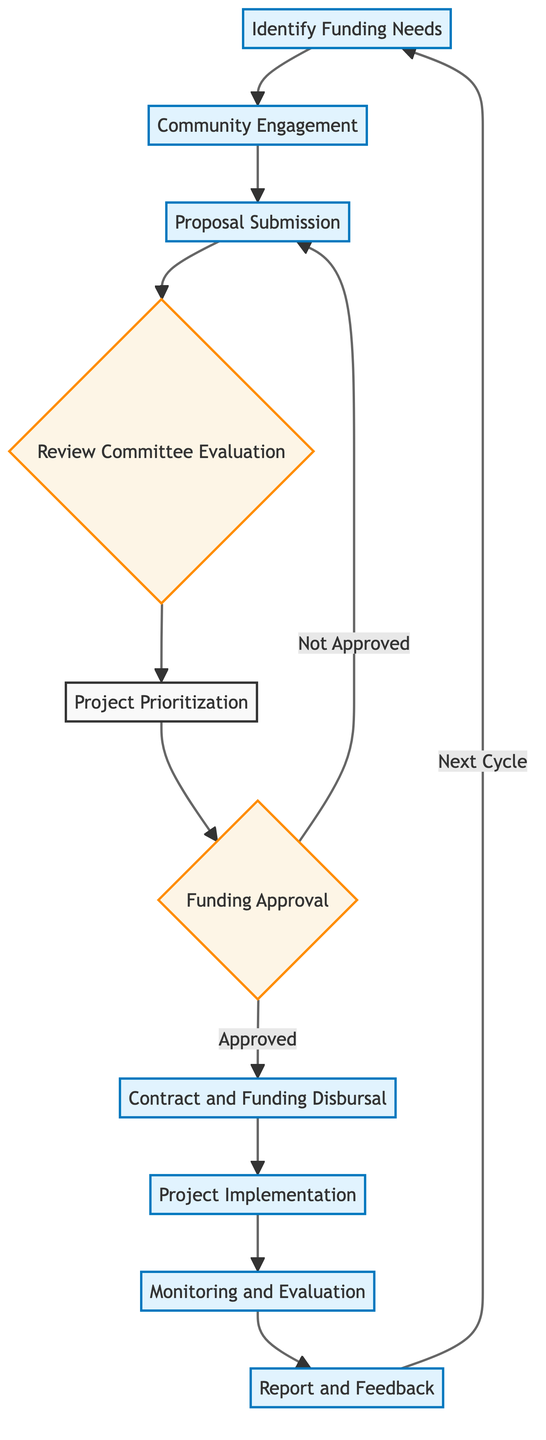What is the first step in the decision-making process? The first step in the diagram is "Identify Funding Needs," which is highlighted as the starting point before community engagement takes place.
Answer: Identify Funding Needs How many nodes are in the flowchart? By counting each distinct labeled box within the flowchart, we identify a total of ten nodes, ranging from identifying funding needs to report and feedback.
Answer: Ten What happens if a proposal is not approved? According to the diagram, if a proposal is not approved, the flowchart directs to "Proposal Submission," indicating that the proposal will be resubmitted for consideration.
Answer: Proposal Submission What is the purpose of the "Monitoring And Evaluation" step? The "Monitoring And Evaluation" step aims to track the progress and evaluate the outcomes of the funded projects, which is crucial for assessing the impact of the initiatives.
Answer: Track progress and evaluate outcomes What is the relationship between "Project Prioritization" and "Funding Approval"? The relationship is sequential; "Project Prioritization" comes before "Funding Approval," indicating that projects must be ranked based on their alignment with community needs before they receive funding approval.
Answer: Sequential relationship What is the last step in the funding process? The last step in the funding process is "Report And Feedback," which gathers final reports and feedback to inform future funding cycles.
Answer: Report And Feedback What decision follows the "Review Committee Evaluation"? The decision that follows the "Review Committee Evaluation" is "Funding Approval," where the committee decides whether to approve the proposals based on their evaluation.
Answer: Funding Approval How does the "Community Engagement" node connect to the overall flow? "Community Engagement" connects to the overall flow as the second step, emphasizing its role in gathering input from stakeholders before proposal submissions are made.
Answer: Second step What does the flowchart indicate happens after "Project Implementation"? After "Project Implementation," the flowchart indicates a move to "Monitoring And Evaluation," which involves tracking the project’s success and assessing outcomes.
Answer: Monitoring And Evaluation 